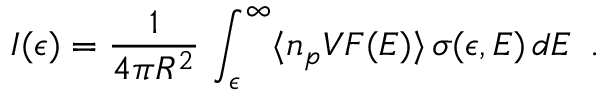<formula> <loc_0><loc_0><loc_500><loc_500>I ( \epsilon ) = \frac { 1 } { 4 \pi R ^ { 2 } } \, \int _ { \epsilon } ^ { \infty } \langle n _ { p } V F ( E ) \rangle \, \sigma ( \epsilon , E ) \, d E \, .</formula> 